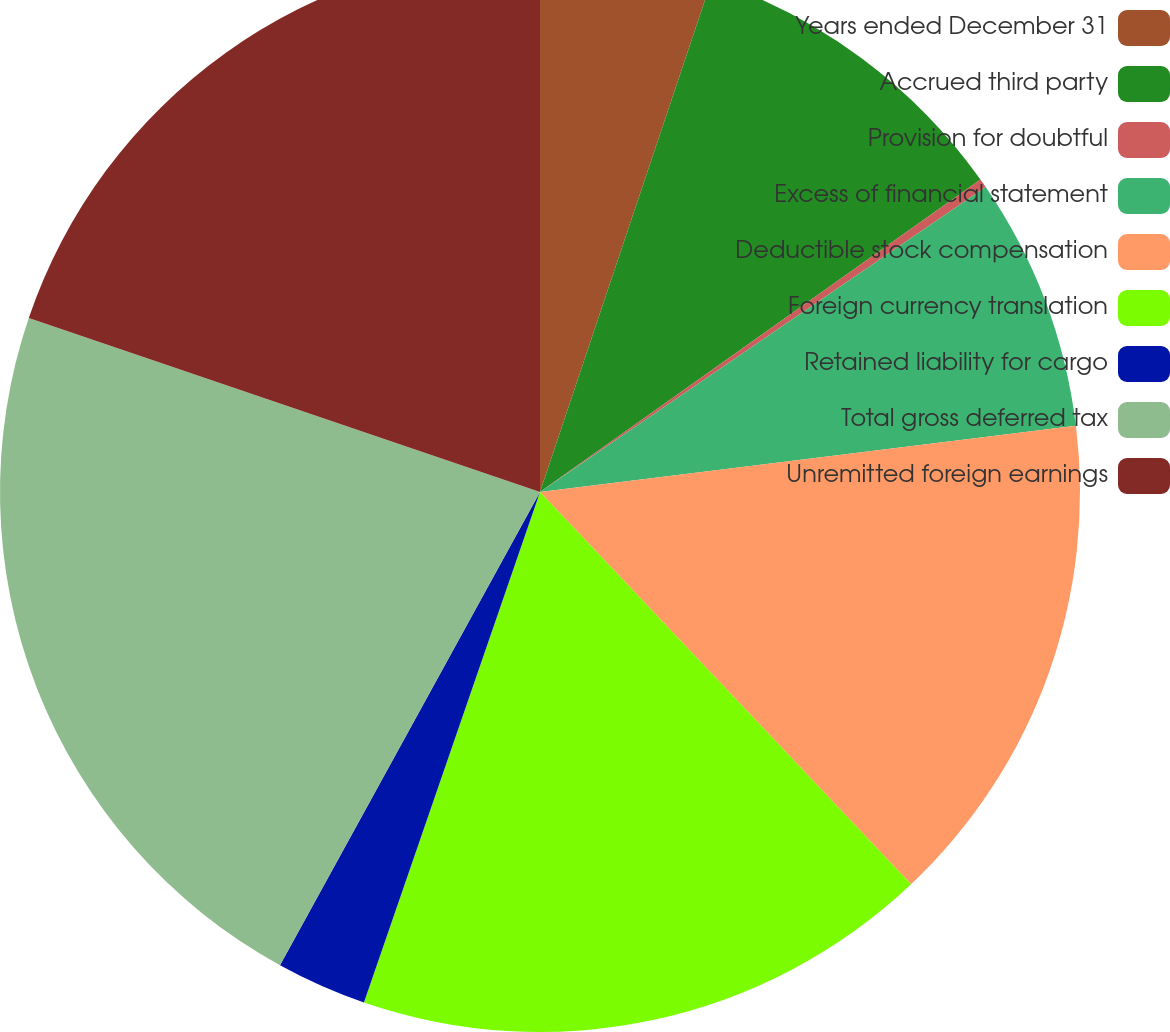<chart> <loc_0><loc_0><loc_500><loc_500><pie_chart><fcel>Years ended December 31<fcel>Accrued third party<fcel>Provision for doubtful<fcel>Excess of financial statement<fcel>Deductible stock compensation<fcel>Foreign currency translation<fcel>Retained liability for cargo<fcel>Total gross deferred tax<fcel>Unremitted foreign earnings<nl><fcel>5.15%<fcel>10.03%<fcel>0.27%<fcel>7.59%<fcel>14.9%<fcel>17.34%<fcel>2.71%<fcel>22.22%<fcel>19.78%<nl></chart> 